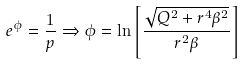Convert formula to latex. <formula><loc_0><loc_0><loc_500><loc_500>e ^ { \phi } = \frac { 1 } { p } \Rightarrow \phi = \ln \left [ \frac { \sqrt { Q ^ { 2 } + r ^ { 4 } \beta ^ { 2 } } } { r ^ { 2 } \beta } \right ]</formula> 